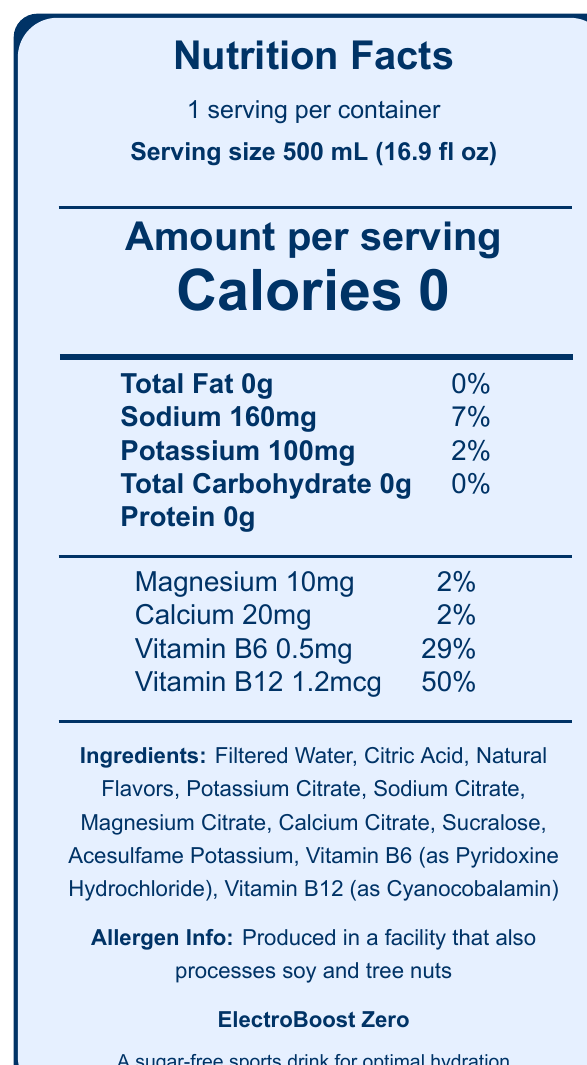who is the manufacturer of ElectroBoost Zero? The document does not include any information about the manufacturer.
Answer: Cannot be determined what is the serving size of ElectroBoost Zero? The document specifies the serving size as 500 mL (16.9 fl oz) on the Nutrition Facts Label.
Answer: 500 mL (16.9 fl oz) how many calories are in one serving of ElectroBoost Zero? The document shows that there are 0 calories per serving.
Answer: 0 what are the zero-calorie sweeteners used in ElectroBoost Zero? The document lists Sucralose and Acesulfame Potassium under the ingredients section.
Answer: Sucralose and Acesulfame Potassium how much sodium is in one serving of ElectroBoost Zero? The document indicates that there are 160mg of sodium per serving.
Answer: 160mg what is the daily value percentage of vitamin B12 in one serving? The document lists that one serving provides 50% of the daily value for vitamin B12.
Answer: 50% ElectroBoost Zero contains which electrolytes? A. Sodium and Potassium B. Magnesium and Calcium C. Both A and B The document includes Sodium, Potassium, Magnesium, and Calcium in the nutrition facts.
Answer: C the product claims to be suitable for which type of physical activity? A. Leisure walking B. Intense physical activity C. Yoga The manufacturer notes mention that the electrolyte blend is optimized for rapid hydration during intense physical activity.
Answer: B is ElectroBoost Zero calorie-free? The document indicates that the product has 0 calories.
Answer: Yes what is the primary purpose of ElectroBoost Zero according to the document? The document specifies that ElectroBoost Zero is a sugar-free sports drink designed for optimal hydration.
Answer: Optimal hydration describe the main idea of the document. The summary encompasses the elements of serving details, nutritional content, key ingredients, product claims, and allergen information as indicated in the document, which outlines the key aspects and purpose of ElectroBoost Zero.
Answer: The document is a nutrition facts label for ElectroBoost Zero, a sugar-free sports drink. It provides detailed information on serving size, calorie content, electrolyte levels, vitamins, ingredients, allergen information, and manufacturer notes, emphasizing the product's suitability for rapid hydration during intense physical activity. 